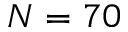Convert formula to latex. <formula><loc_0><loc_0><loc_500><loc_500>N = 7 0</formula> 